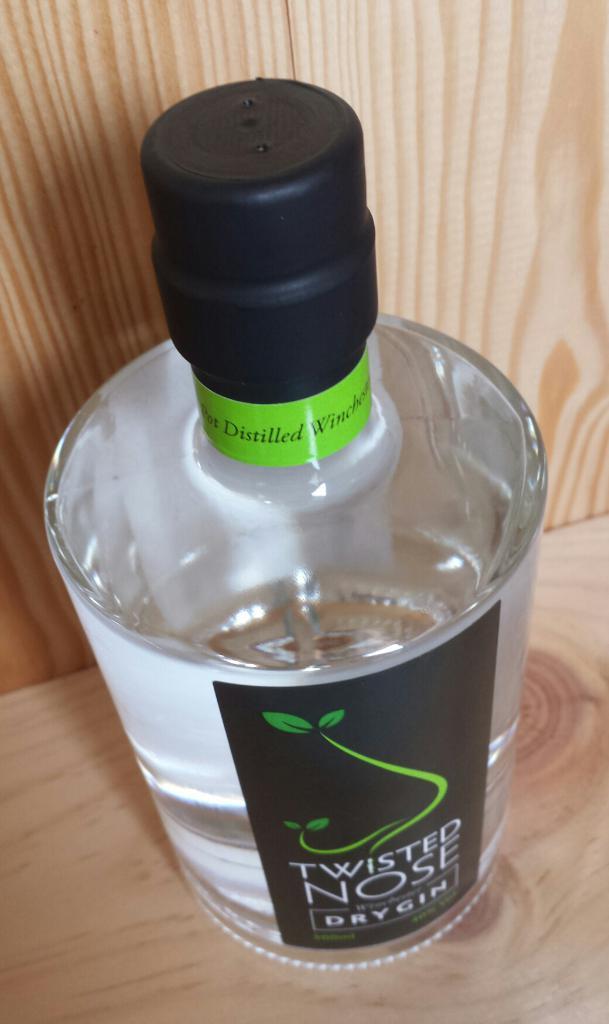What is the type of gin?
Your response must be concise. Dry. 